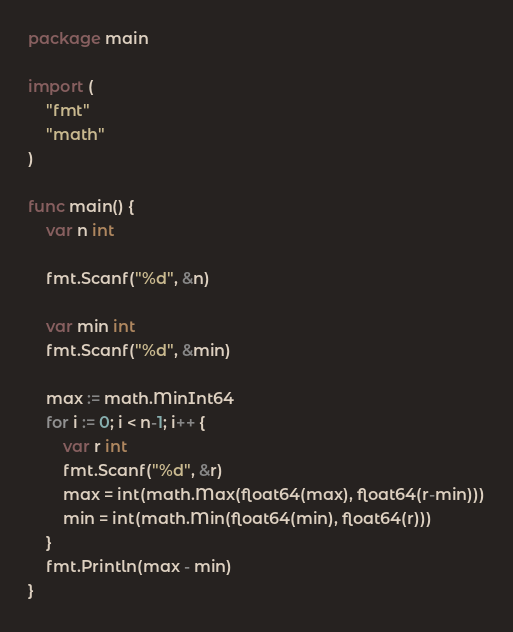Convert code to text. <code><loc_0><loc_0><loc_500><loc_500><_Go_>package main

import (
	"fmt"
	"math"
)

func main() {
	var n int

	fmt.Scanf("%d", &n)

	var min int
	fmt.Scanf("%d", &min)

	max := math.MinInt64
	for i := 0; i < n-1; i++ {
		var r int
		fmt.Scanf("%d", &r)
		max = int(math.Max(float64(max), float64(r-min)))
		min = int(math.Min(float64(min), float64(r)))
	}
	fmt.Println(max - min)
}
</code> 